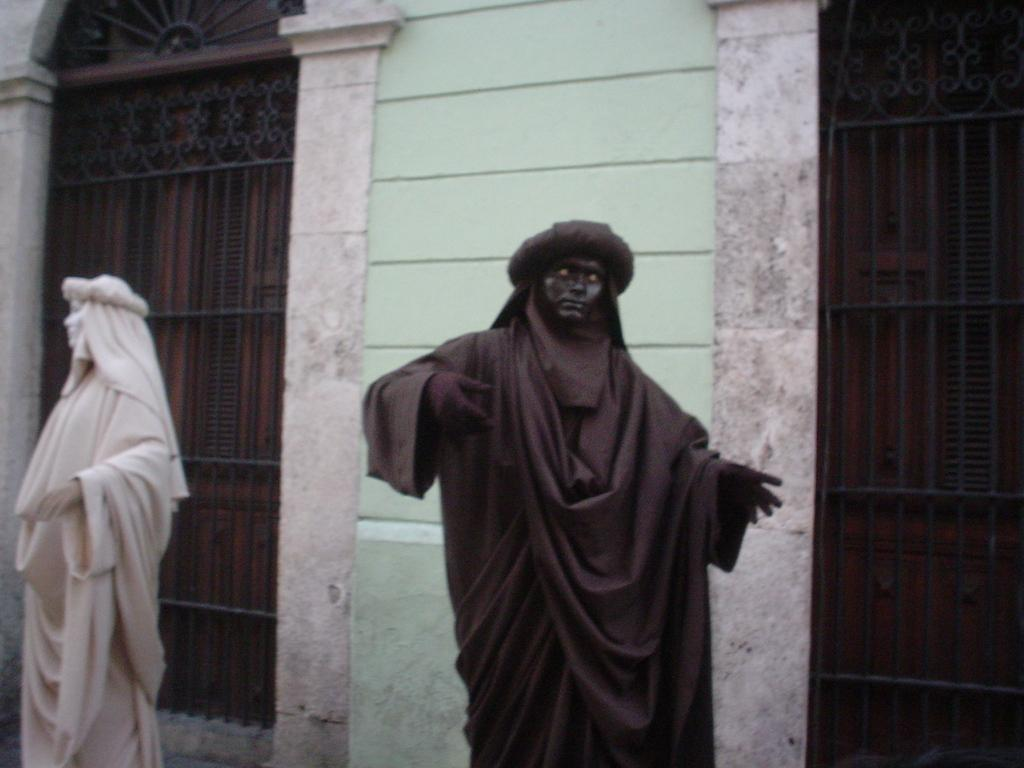What can be seen in the image besides the building in the background? There are statues in the image. What material can be seen in the background of the image? There are metal rods in the background of the image. What type of joke is being told by the statues in the image? There is no indication in the image that the statues are telling a joke; they are simply standing in the image. What is the condition of the stem in the image? There is no stem present in the image. 